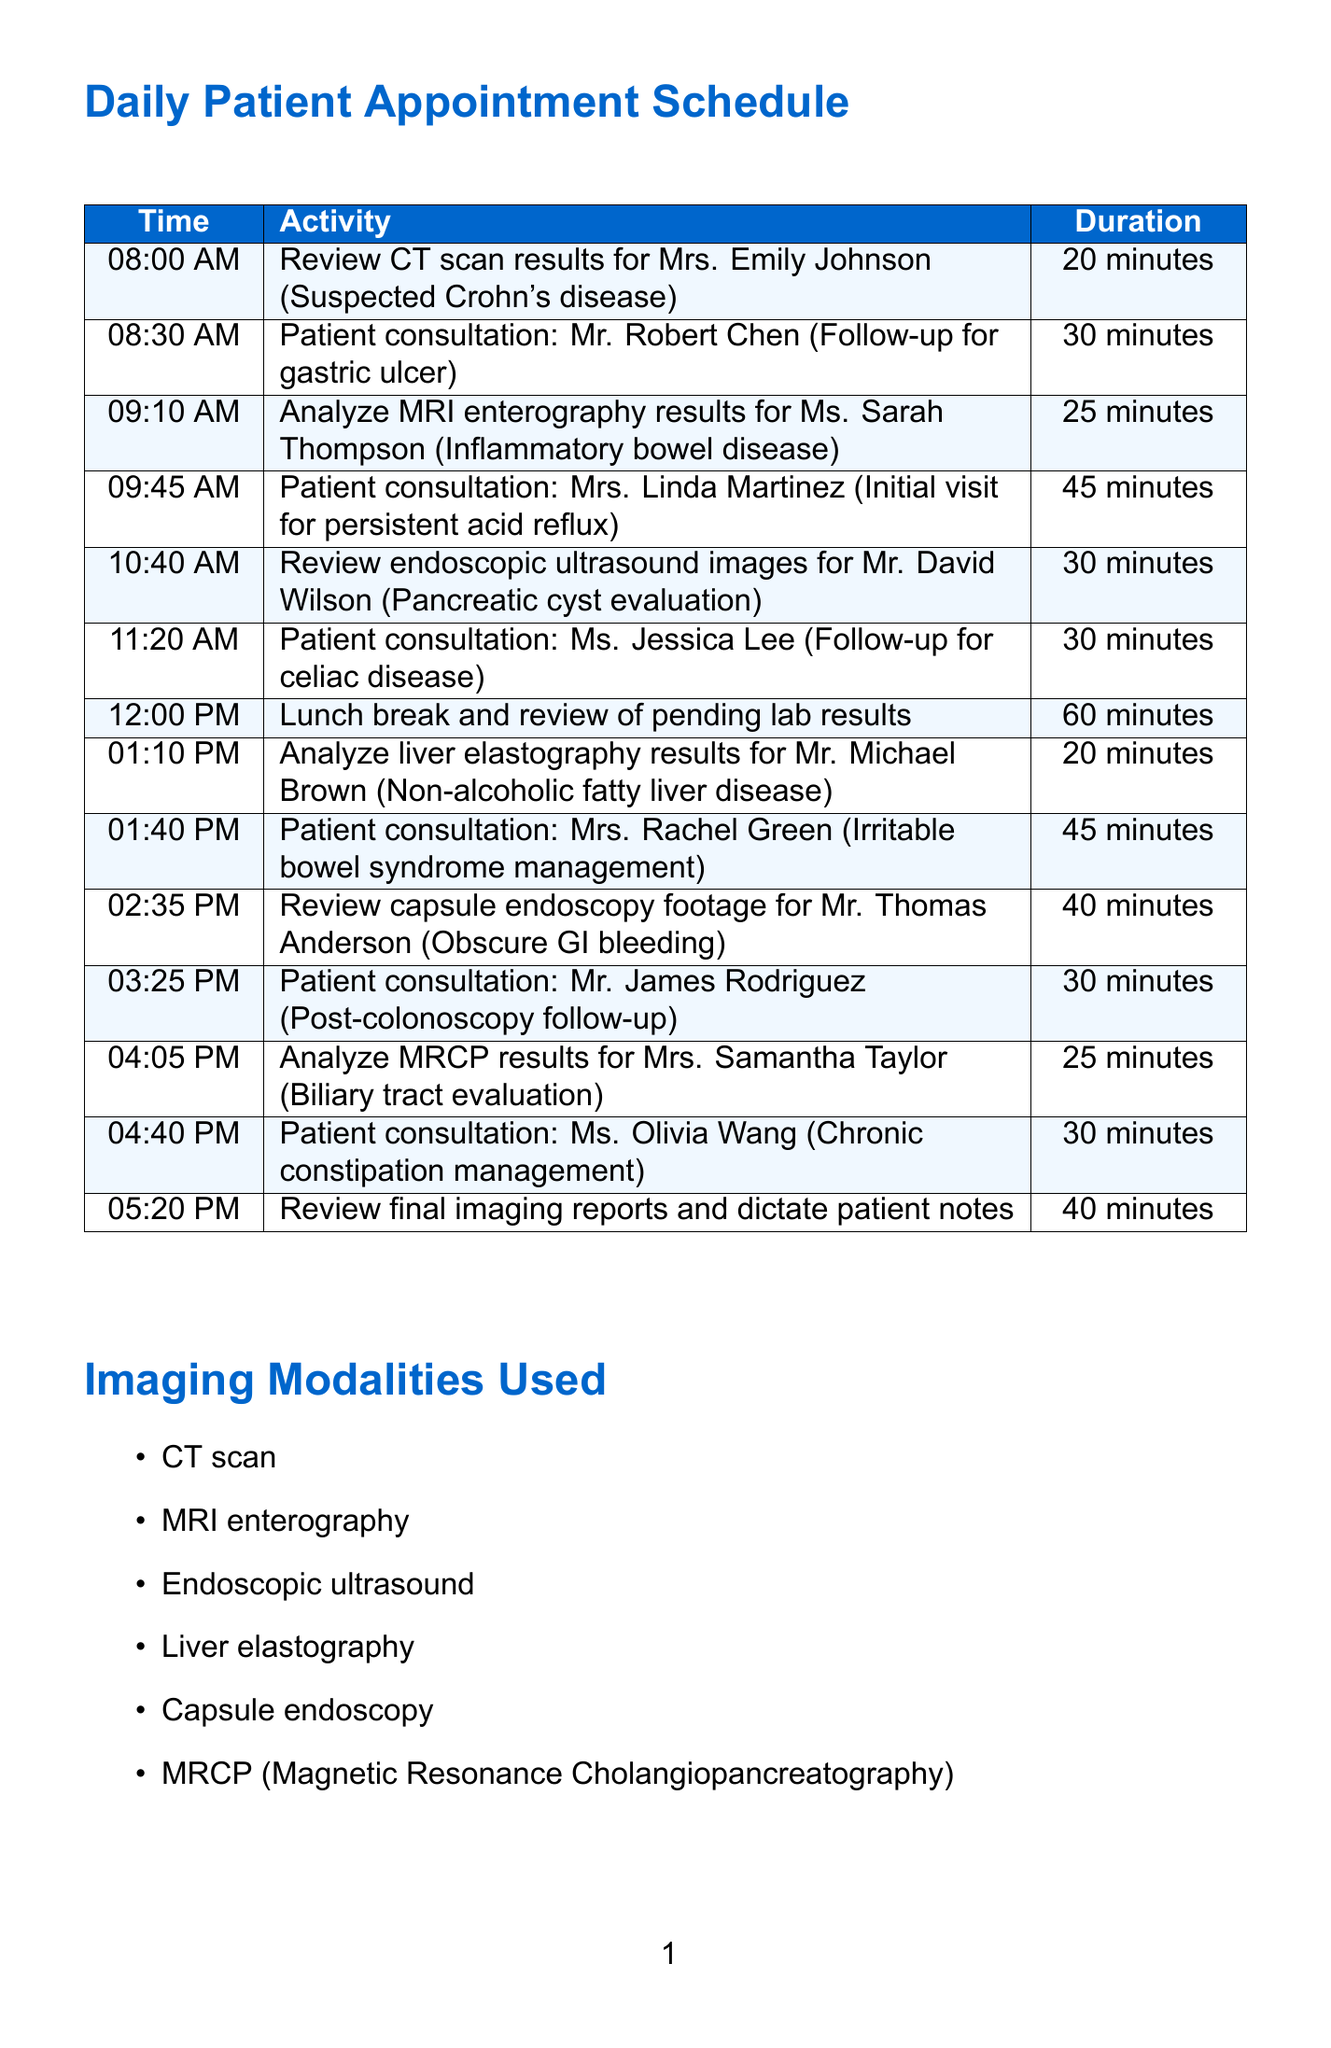What is the first activity scheduled for the day? The first activity is listed in the document at 08:00 AM, which is the review of CT scan results for a specific patient.
Answer: Review CT scan results for Mrs. Emily Johnson (Suspected Crohn's disease) What time is the lunch break scheduled? The lunch break is mentioned in the document along with its start time and duration.
Answer: 12:00 PM How long is the review of capsule endoscopy footage for Mr. Thomas Anderson? The document provides the duration of the review activity for this patient.
Answer: 40 minutes Which imaging modality is used for evaluating pancreatic cysts? This information can be found in the list of imaging modalities and the corresponding activity in the schedule.
Answer: Endoscopic ultrasound What is the common condition being followed up for Mr. Robert Chen? The document links patient consultations with their corresponding conditions, leading to this specific follow-up case.
Answer: Gastric ulcer How many consultation appointments are scheduled in the morning? The document shows the number of patient consultations scheduled up until 12 PM.
Answer: Three What patient condition is Mrs. Rachel Green being managed for? The condition is stated next to her patient consultation activity in the schedule.
Answer: Irritable bowel syndrome What is the purpose of analyzing liver elastography results? The context of the activity in the schedule suggests why these results are being analyzed, based on the patient’s condition.
Answer: Non-alcoholic fatty liver disease 